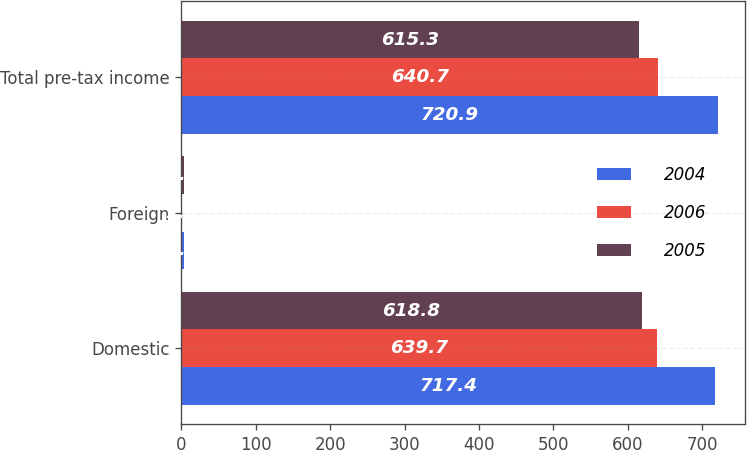<chart> <loc_0><loc_0><loc_500><loc_500><stacked_bar_chart><ecel><fcel>Domestic<fcel>Foreign<fcel>Total pre-tax income<nl><fcel>2004<fcel>717.4<fcel>3.5<fcel>720.9<nl><fcel>2006<fcel>639.7<fcel>1<fcel>640.7<nl><fcel>2005<fcel>618.8<fcel>3.5<fcel>615.3<nl></chart> 